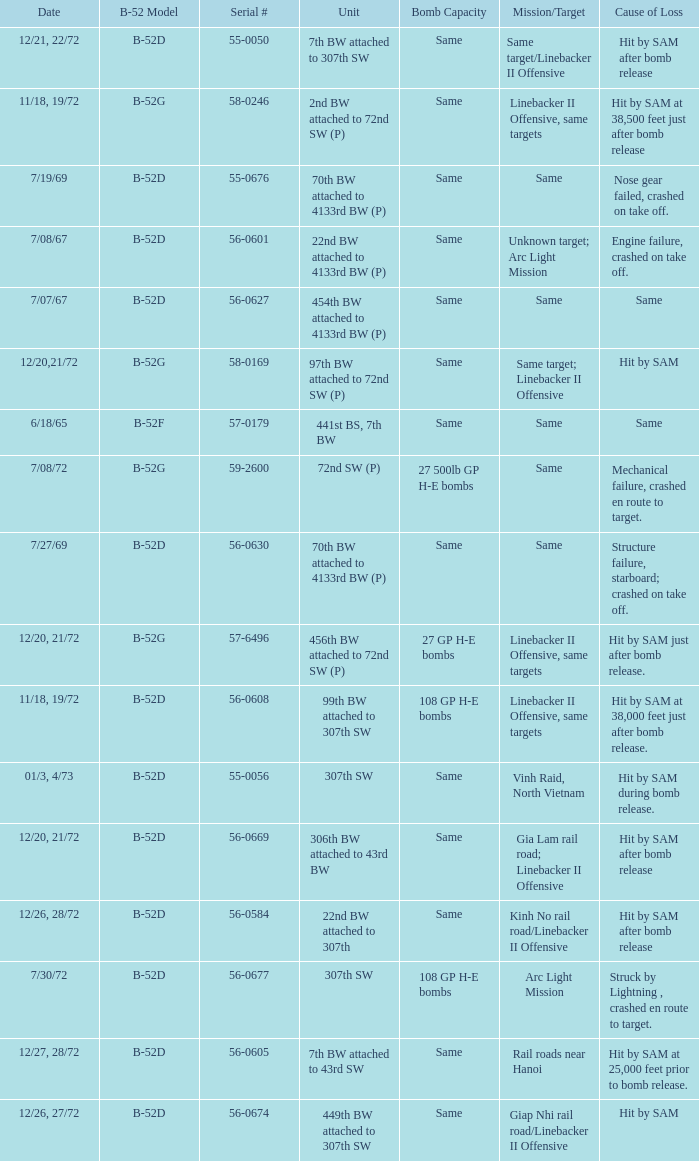When hit by sam at 38,500 feet just after bomb release was the cause of loss what is the mission/target? Linebacker II Offensive, same targets. 